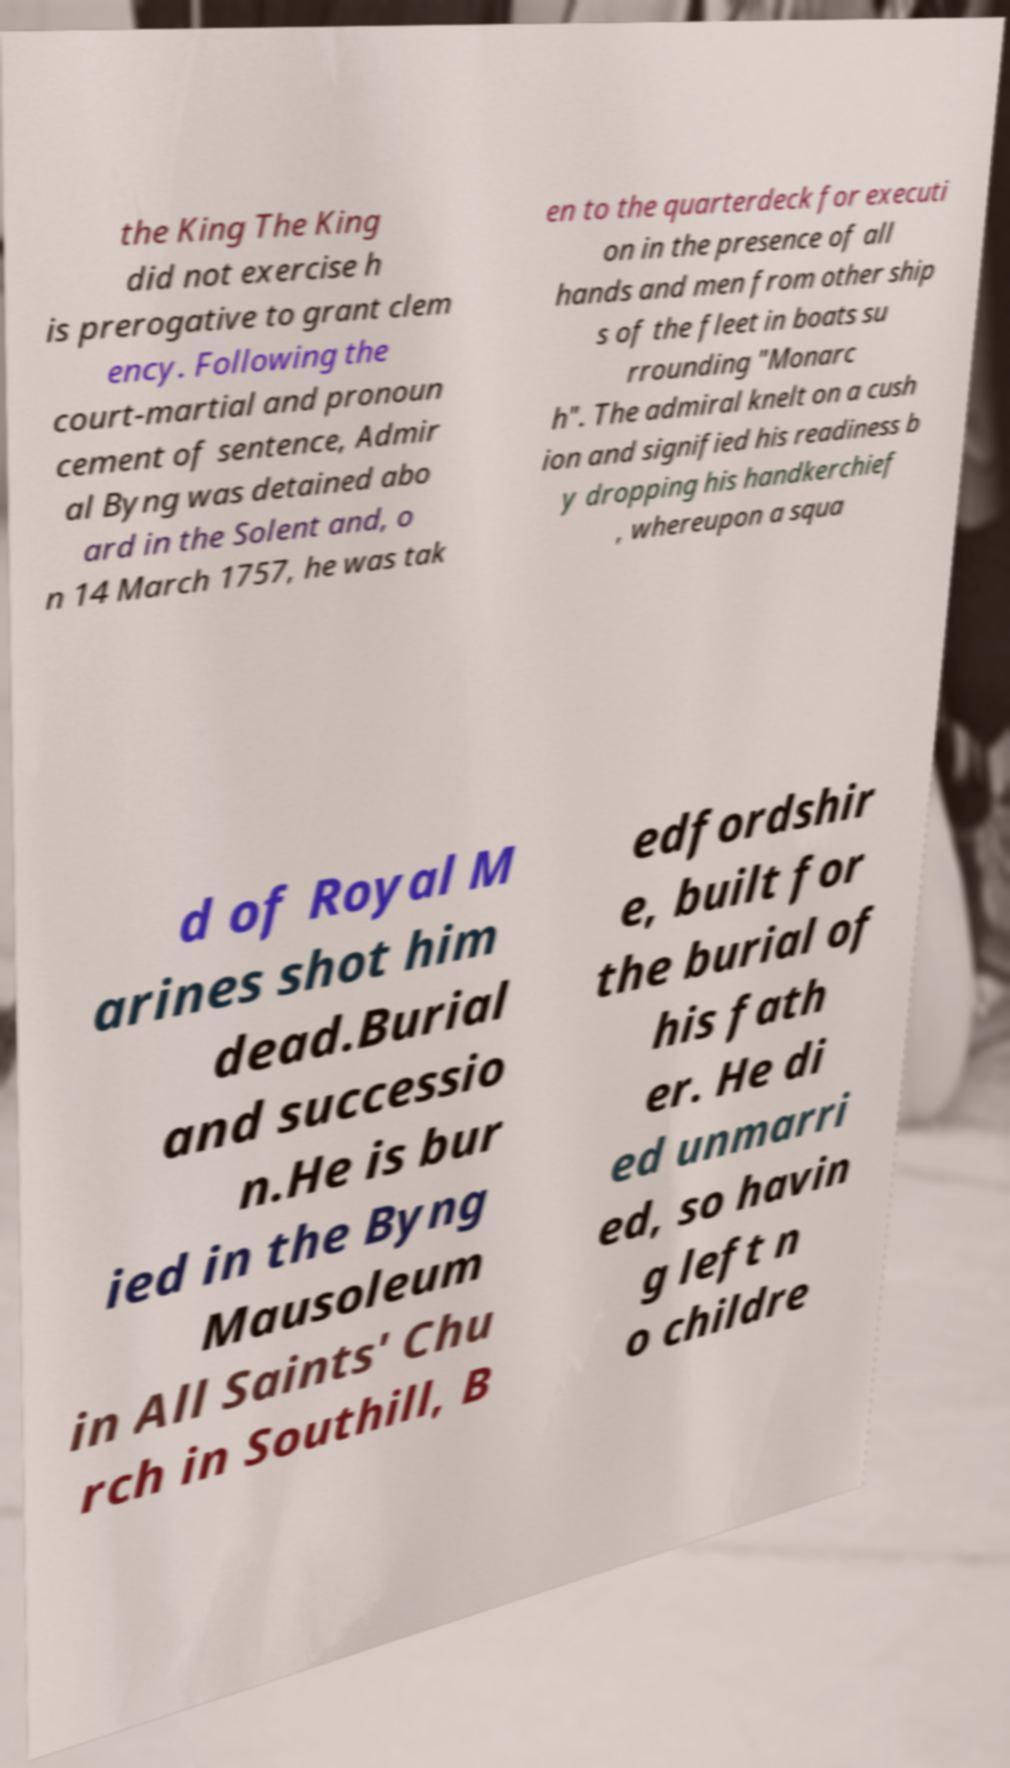What messages or text are displayed in this image? I need them in a readable, typed format. the King The King did not exercise h is prerogative to grant clem ency. Following the court-martial and pronoun cement of sentence, Admir al Byng was detained abo ard in the Solent and, o n 14 March 1757, he was tak en to the quarterdeck for executi on in the presence of all hands and men from other ship s of the fleet in boats su rrounding "Monarc h". The admiral knelt on a cush ion and signified his readiness b y dropping his handkerchief , whereupon a squa d of Royal M arines shot him dead.Burial and successio n.He is bur ied in the Byng Mausoleum in All Saints' Chu rch in Southill, B edfordshir e, built for the burial of his fath er. He di ed unmarri ed, so havin g left n o childre 